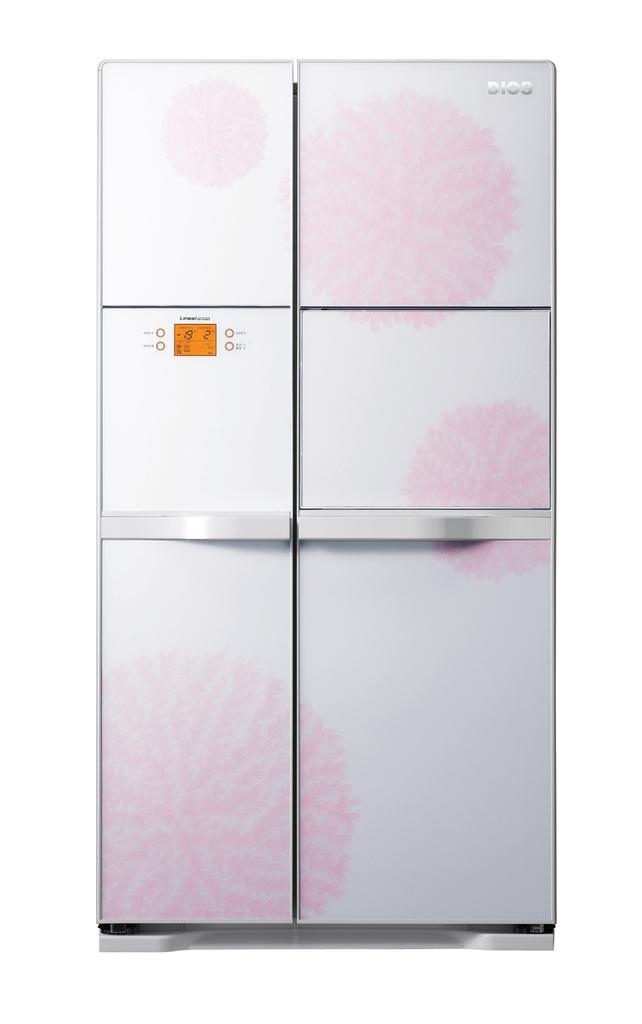Please provide a concise description of this image. In the foreground of this image, there is a refrigerator and the white background. 